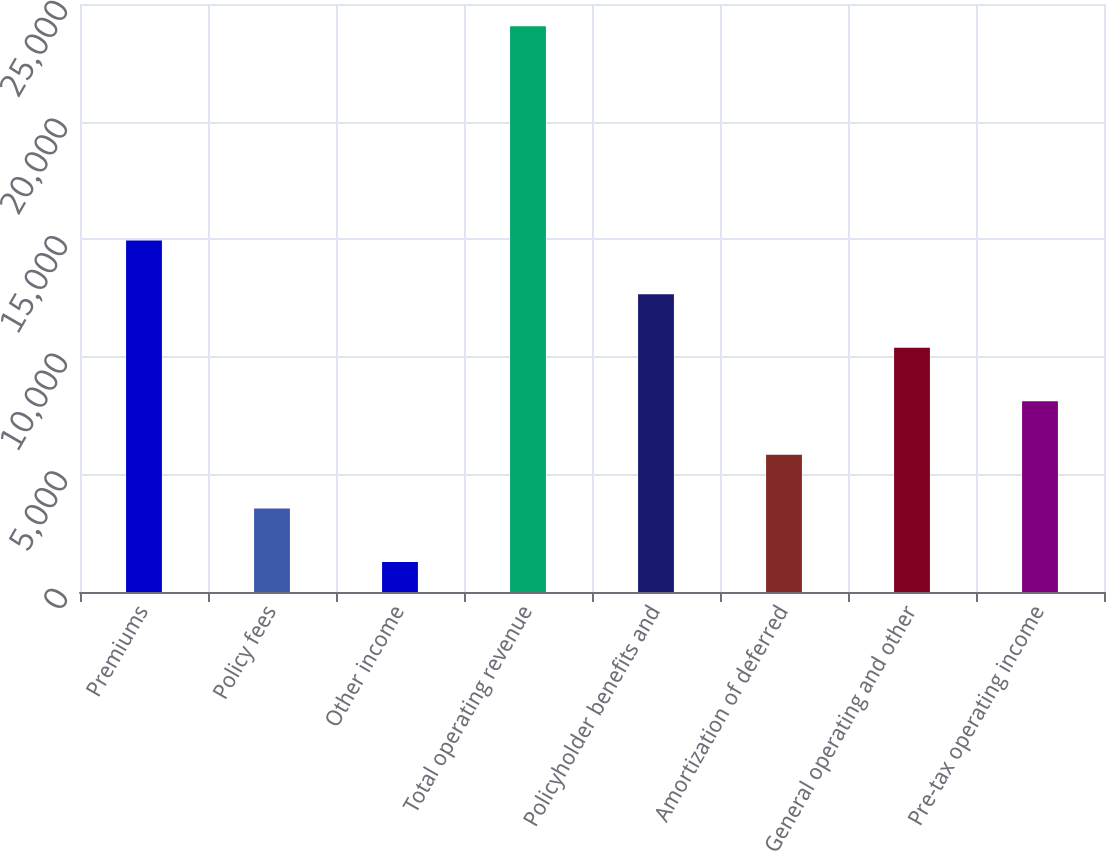<chart> <loc_0><loc_0><loc_500><loc_500><bar_chart><fcel>Premiums<fcel>Policy fees<fcel>Other income<fcel>Total operating revenue<fcel>Policyholder benefits and<fcel>Amortization of deferred<fcel>General operating and other<fcel>Pre-tax operating income<nl><fcel>14940.6<fcel>3555.1<fcel>1278<fcel>24049<fcel>12663.5<fcel>5832.2<fcel>10386.4<fcel>8109.3<nl></chart> 